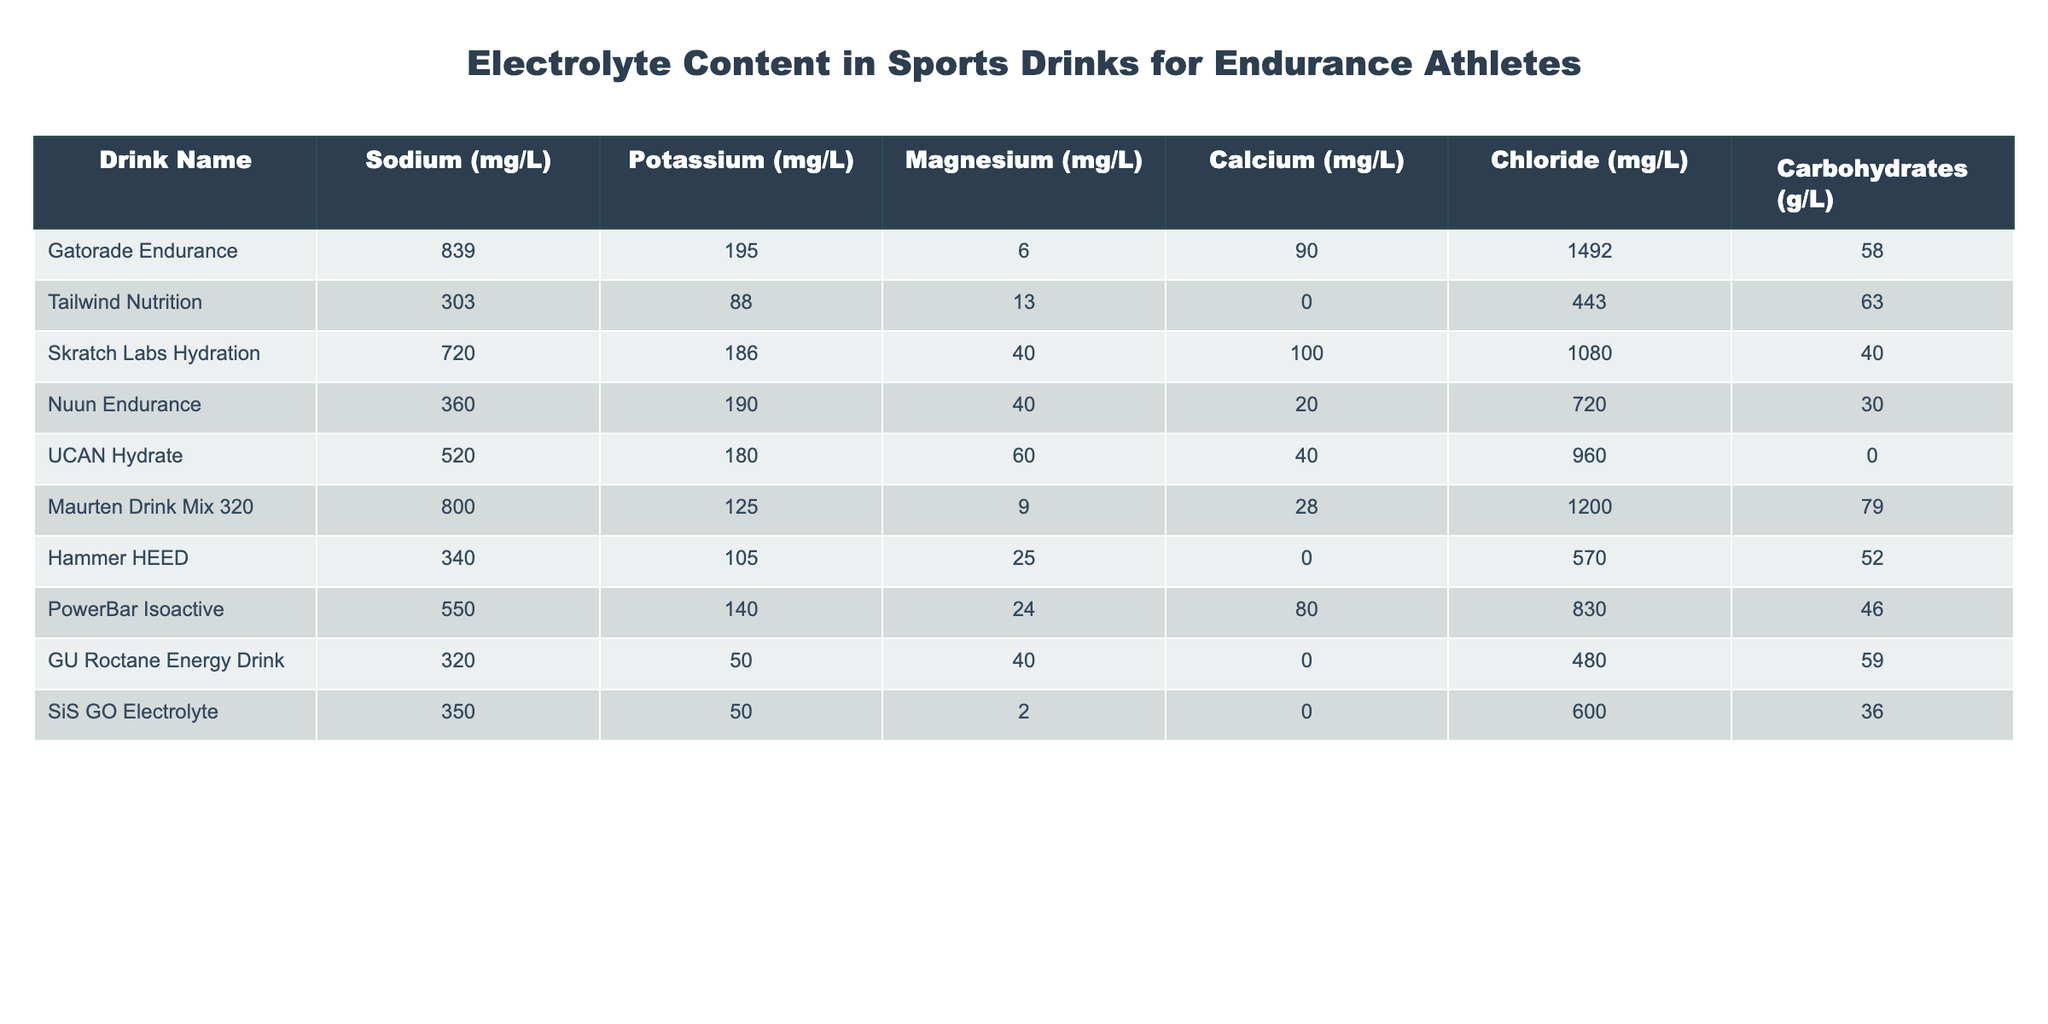What is the beverage with the highest sodium content? By reviewing the Sodium values in the table, Gatorade Endurance is listed with a Sodium content of 839 mg/L, which is higher than any other drink's Sodium content.
Answer: Gatorade Endurance How much potassium is present in Skratch Labs Hydration? Looking at the Potassium column for Skratch Labs Hydration, it shows a value of 186 mg/L.
Answer: 186 mg/L Which drink has the highest carbohydrate content? The Carbohydrates column indicates that UCAN Hydrate has 0 g/L, which is the lowest, while Gatorade Endurance has the highest at 58 g/L.
Answer: Gatorade Endurance What is the total amount of Magnesium in all the drinks combined? Summing the Magnesium values: 6 + 13 + 40 + 40 + 60 + 9 + 25 + 24 + 40 + 2 = 274 mg/L.
Answer: 274 mg/L Which drink provides the most Chloride? Chloride content of all drinks shows that Gatorade Endurance has the highest at 1492 mg/L, surpassing all other options.
Answer: Gatorade Endurance Is there any drink with zero carbohydrates? Checking the Carbohydrates column, UCAN Hydrate shows 0 g/L, confirming that it has no carbohydrates.
Answer: Yes Which drink offers the combined total of Sodium and Potassium that exceeds 1000 mg/L? We need to analyze the Sodium and Potassium values. Gatorade Endurance: 839 + 195 = 1034 mg/L; Tailwind: 303 + 88 = 391 mg/L; UCAN: 520 + 180 = 700 mg/L; and Maurten: 800 + 125 = 925 mg/L. Only Gatorade Endurance exceeds 1000 mg/L.
Answer: Gatorade Endurance What drink has the highest Calcium and what is its value? The Calcium column shows that Skratch Labs Hydration has the highest Calcium content at 100 mg/L compared to others.
Answer: Skratch Labs Hydration, 100 mg/L Which two drinks have Magnesium contents that average more than 30 mg/L? The Magnesium contents to evaluate are: Skratch Labs Hydration (40), Nuun Endurance (40), and UCAN Hydrate (60). Their average (40 + 40 + 60) / 3 = 46.7 mg/L is above 30 mg/L.
Answer: Skratch Labs Hydration, Nuun Endurance, UCAN Hydrate How does the Sodium content of Hammer HEED compare to PowerBar Isoactive? Hammer HEED has a Sodium content of 340 mg/L, while PowerBar Isoactive has 550 mg/L. The comparison shows PowerBar Isoactive has more Sodium.
Answer: PowerBar Isoactive has more Sodium 